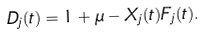Convert formula to latex. <formula><loc_0><loc_0><loc_500><loc_500>D _ { j } ( t ) = 1 + \mu - X _ { j } ( t ) F _ { j } ( t ) .</formula> 